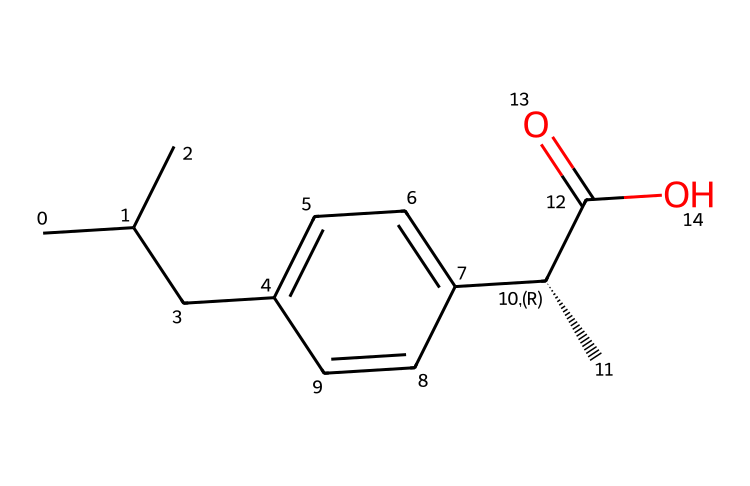How many carbon atoms are in ibuprofen? By analyzing the SMILES representation, we can count all the carbon (C) atoms in the structure. The central chain and the aromatic ring both contain a total of 13 carbon atoms.
Answer: 13 What is the functional group present in ibuprofen? The SMILES indicates a carboxylic acid functional group, which is identified by the presence of the "C(=O)O" part at the end of the structure.
Answer: carboxylic acid Does ibuprofen contain any chiral centers? In the SMILES structure, the specific notation "[C@@H]" indicates the presence of a chiral center due to its stereochemistry. Thus, there is one chiral center.
Answer: one What type of compound is ibuprofen classified as? Given its molecular structure and usage, ibuprofen is classified as a nonsteroidal anti-inflammatory drug (NSAID) based on its characteristics and effects on pain and inflammation.
Answer: nonsteroidal anti-inflammatory drug How many double bonds are in ibuprofen? Examining the SMILES representation, we find that there is one double bond in the structure, indicated by "C(=O)," with the carbonyl group forming a double bond with oxygen.
Answer: one What role does the carboxylic acid group play in ibuprofen's activity? The carboxylic acid group contributes to the drug's solubility in water and is crucial for its anti-inflammatory and analgesic activities, enabling interaction with biological targets.
Answer: solubility and activity 